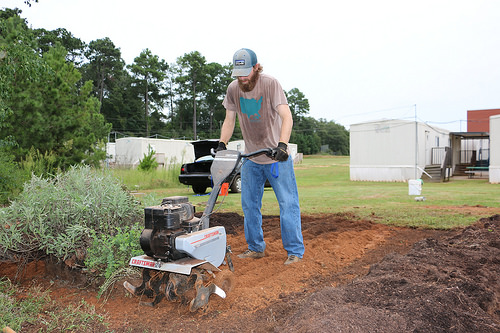<image>
Can you confirm if the cap is behind the rototiller? Yes. From this viewpoint, the cap is positioned behind the rototiller, with the rototiller partially or fully occluding the cap. 